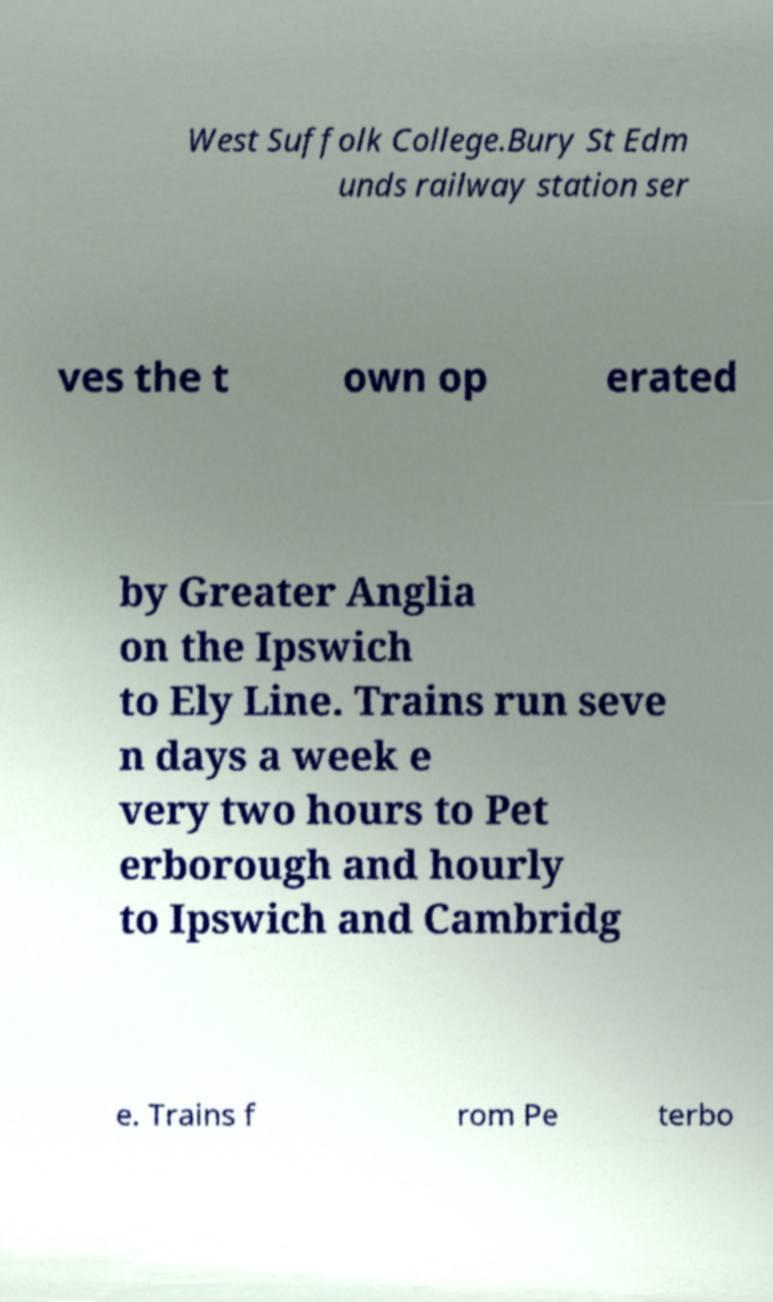Could you assist in decoding the text presented in this image and type it out clearly? West Suffolk College.Bury St Edm unds railway station ser ves the t own op erated by Greater Anglia on the Ipswich to Ely Line. Trains run seve n days a week e very two hours to Pet erborough and hourly to Ipswich and Cambridg e. Trains f rom Pe terbo 